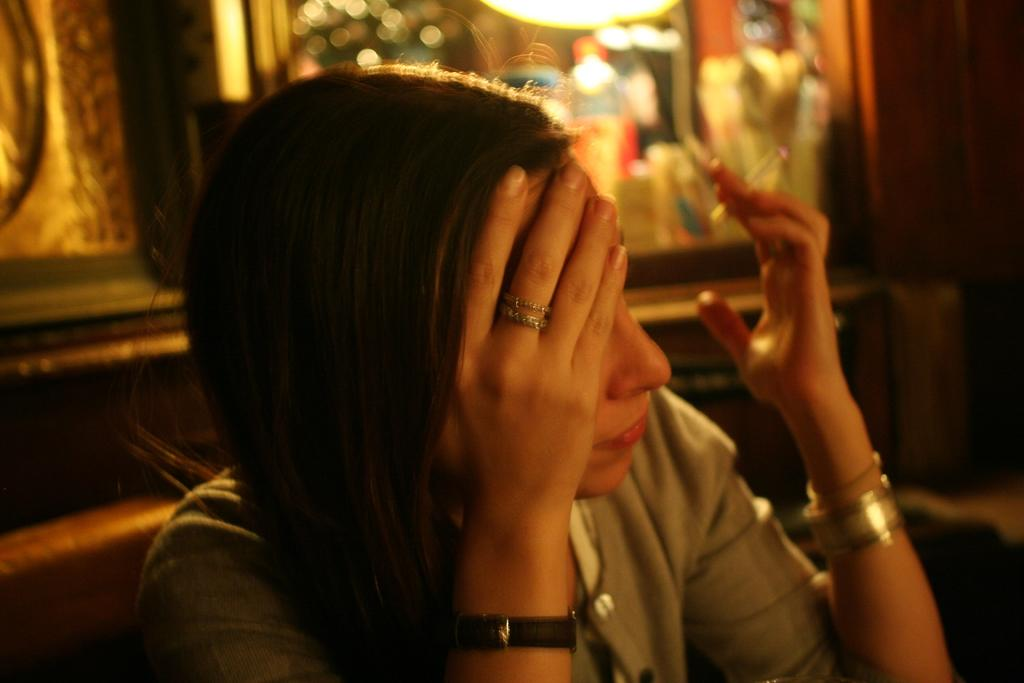Who is present in the image? There is a woman in the image. What is the woman wearing? The woman is wearing clothes, a wristwatch, a bracelet, and a ring on her finger. What is the woman holding in her hand? The woman is holding a cigarette in her hand. What can be observed about the background of the image? The background of the image is blurred. What type of glass is the woman drinking from in the image? There is no glass present in the image; the woman is holding a cigarette. 